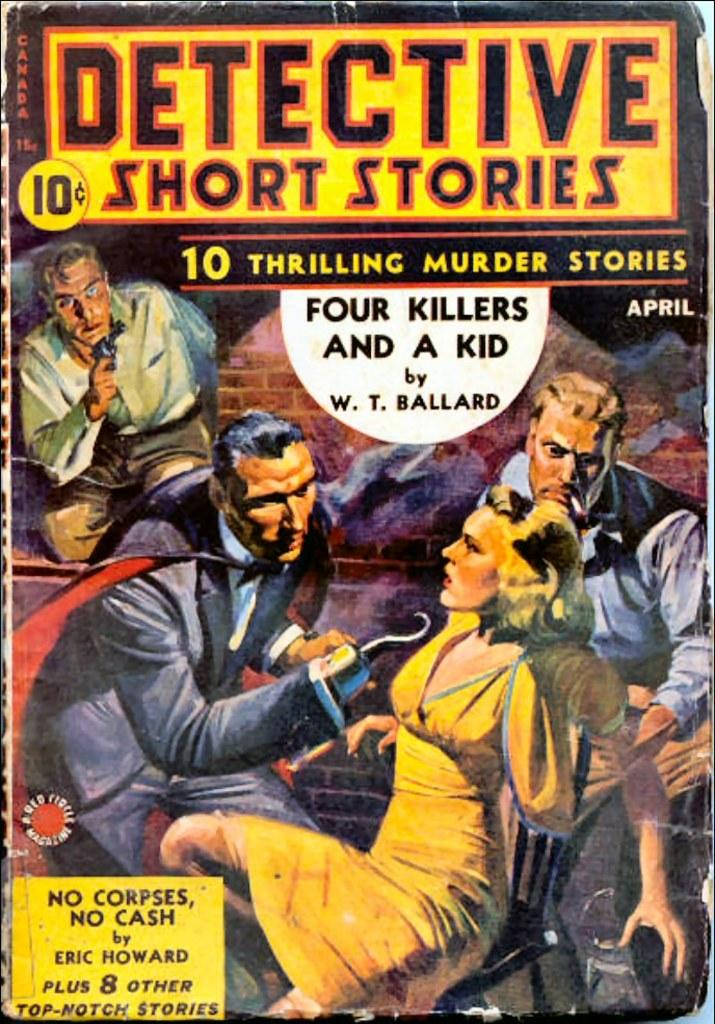<image>
Share a concise interpretation of the image provided. A book of ten short stories about detectives and murder. 